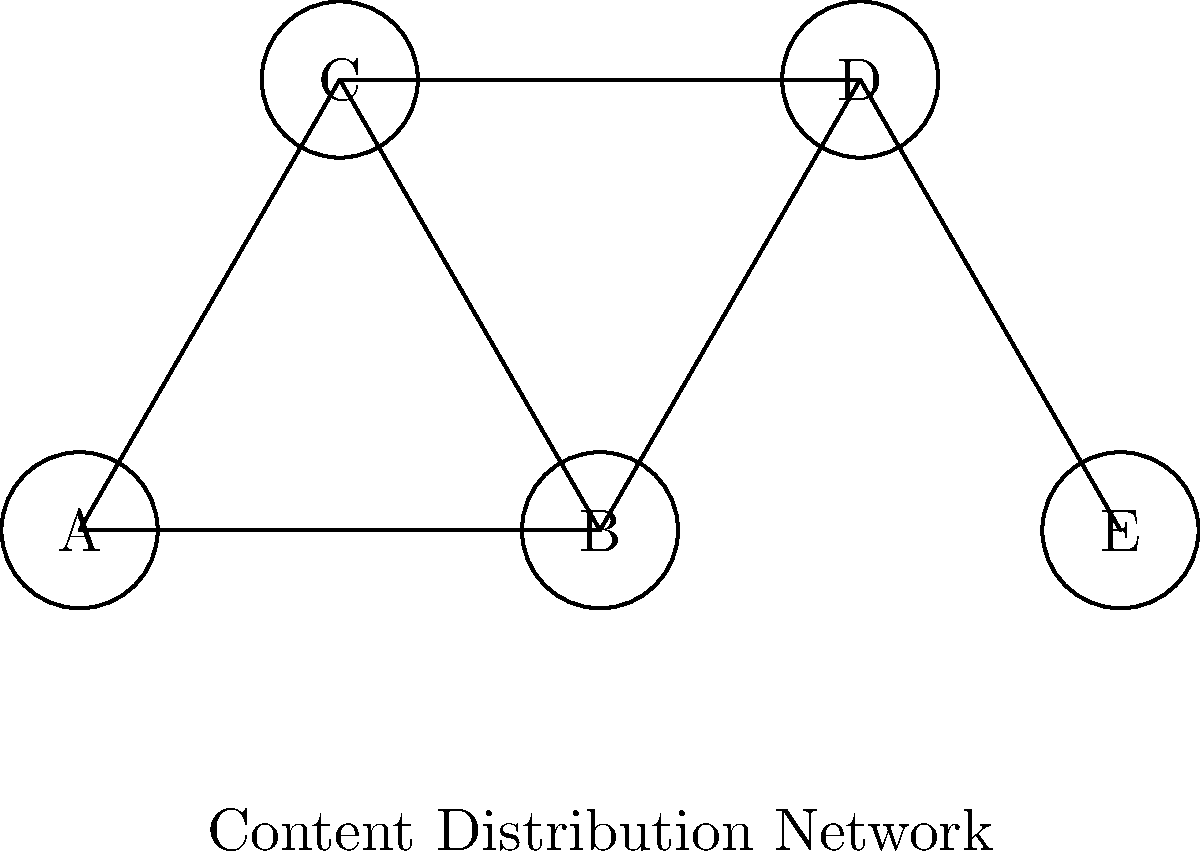In the context of content distribution channels, consider the network graph representing various platforms. If node A represents your primary content hub, and you want to ensure your content reaches node E, what is the minimum number of intermediate nodes your content must pass through? How does this relate to the concept of network connectedness in content strategy? To solve this problem and understand its relevance to content strategy, let's follow these steps:

1. Analyze the graph structure:
   The graph represents a content distribution network where nodes are platforms and edges are connections between them.

2. Identify the start and end points:
   - Start: Node A (primary content hub)
   - End: Node E (target platform)

3. Find all possible paths from A to E:
   - A → B → D → E
   - A → C → D → E
   - A → B → C → D → E

4. Determine the shortest path:
   The shortest paths are A → B → D → E and A → C → D → E, both with two intermediate nodes (B and D, or C and D).

5. Count the minimum number of intermediate nodes:
   In both shortest paths, there are 2 intermediate nodes.

6. Relate to network connectedness in content strategy:
   - The number of intermediate nodes represents the "degrees of separation" in your content distribution network.
   - Fewer intermediate nodes mean higher connectedness and potentially faster, more efficient content distribution.
   - In content strategy, this concept is crucial for understanding how quickly and directly your content can reach target platforms or audiences.
   - A well-connected network allows for more control over content dissemination and potentially broader reach.

7. Strategic implications:
   - Content writers should consider optimizing distribution channels to minimize intermediaries.
   - Building direct connections to key platforms (like E in this case) could improve content reach and engagement.
   - Understanding the network structure helps in planning content adaptation for different platforms along the distribution path.
Answer: 2 intermediate nodes; higher connectedness enables more efficient content distribution. 